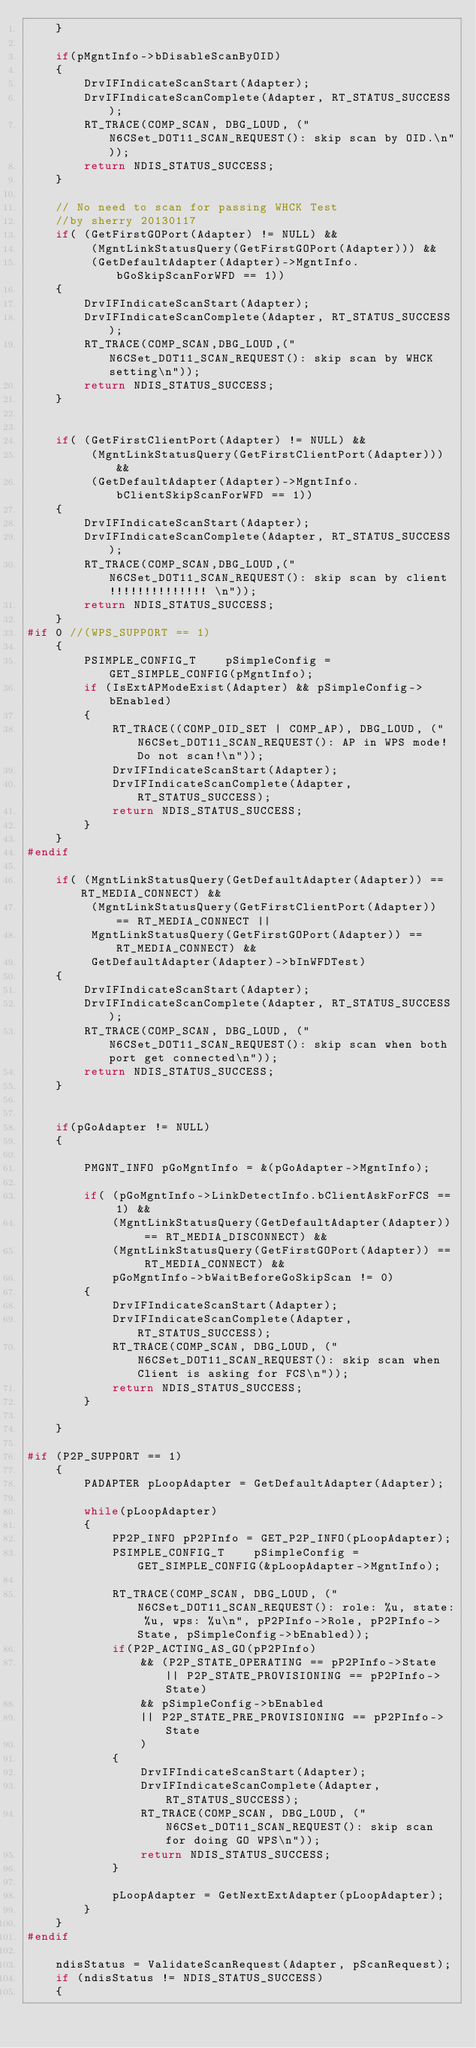Convert code to text. <code><loc_0><loc_0><loc_500><loc_500><_C_>	}

	if(pMgntInfo->bDisableScanByOID)
	{
		DrvIFIndicateScanStart(Adapter);
		DrvIFIndicateScanComplete(Adapter, RT_STATUS_SUCCESS);
		RT_TRACE(COMP_SCAN, DBG_LOUD, ("N6CSet_DOT11_SCAN_REQUEST(): skip scan by OID.\n"));
		return NDIS_STATUS_SUCCESS;
	}

	// No need to scan for passing WHCK Test 
	//by sherry 20130117
	if( (GetFirstGOPort(Adapter) != NULL) && 
		 (MgntLinkStatusQuery(GetFirstGOPort(Adapter))) &&
		 (GetDefaultAdapter(Adapter)->MgntInfo.bGoSkipScanForWFD == 1))
	{
		DrvIFIndicateScanStart(Adapter);
		DrvIFIndicateScanComplete(Adapter, RT_STATUS_SUCCESS);
		RT_TRACE(COMP_SCAN,DBG_LOUD,("N6CSet_DOT11_SCAN_REQUEST(): skip scan by WHCK setting\n"));
		return NDIS_STATUS_SUCCESS;
	}

	
	if( (GetFirstClientPort(Adapter) != NULL) && 
		 (MgntLinkStatusQuery(GetFirstClientPort(Adapter))) &&
		 (GetDefaultAdapter(Adapter)->MgntInfo.bClientSkipScanForWFD == 1))
	{
		DrvIFIndicateScanStart(Adapter);
		DrvIFIndicateScanComplete(Adapter, RT_STATUS_SUCCESS);
		RT_TRACE(COMP_SCAN,DBG_LOUD,("N6CSet_DOT11_SCAN_REQUEST(): skip scan by client!!!!!!!!!!!!!! \n"));
		return NDIS_STATUS_SUCCESS;
	}
#if 0 //(WPS_SUPPORT == 1)
	{
		PSIMPLE_CONFIG_T	pSimpleConfig = GET_SIMPLE_CONFIG(pMgntInfo);
		if (IsExtAPModeExist(Adapter) && pSimpleConfig->bEnabled)
		{
			RT_TRACE((COMP_OID_SET | COMP_AP), DBG_LOUD, ("N6CSet_DOT11_SCAN_REQUEST(): AP in WPS mode! Do not scan!\n"));
			DrvIFIndicateScanStart(Adapter);
			DrvIFIndicateScanComplete(Adapter, RT_STATUS_SUCCESS);
			return NDIS_STATUS_SUCCESS;
		}
	}
#endif

	if( (MgntLinkStatusQuery(GetDefaultAdapter(Adapter)) == RT_MEDIA_CONNECT) &&
		 (MgntLinkStatusQuery(GetFirstClientPort(Adapter)) == RT_MEDIA_CONNECT ||
		 MgntLinkStatusQuery(GetFirstGOPort(Adapter)) == RT_MEDIA_CONNECT) &&
		 GetDefaultAdapter(Adapter)->bInWFDTest)
	{
		DrvIFIndicateScanStart(Adapter);
		DrvIFIndicateScanComplete(Adapter, RT_STATUS_SUCCESS);
		RT_TRACE(COMP_SCAN, DBG_LOUD, ("N6CSet_DOT11_SCAN_REQUEST(): skip scan when both port get connected\n"));
		return NDIS_STATUS_SUCCESS;
	}


	if(pGoAdapter != NULL)
	{

		PMGNT_INFO pGoMgntInfo = &(pGoAdapter->MgntInfo);
		
		if(	(pGoMgntInfo->LinkDetectInfo.bClientAskForFCS == 1) &&	
			(MgntLinkStatusQuery(GetDefaultAdapter(Adapter)) == RT_MEDIA_DISCONNECT) &&
			(MgntLinkStatusQuery(GetFirstGOPort(Adapter)) == RT_MEDIA_CONNECT) &&
		 	pGoMgntInfo->bWaitBeforeGoSkipScan != 0)
		{
			DrvIFIndicateScanStart(Adapter);
			DrvIFIndicateScanComplete(Adapter, RT_STATUS_SUCCESS);
			RT_TRACE(COMP_SCAN, DBG_LOUD, ("N6CSet_DOT11_SCAN_REQUEST(): skip scan when Client is asking for FCS\n"));
			return NDIS_STATUS_SUCCESS;
		}
	
	}
	
#if (P2P_SUPPORT == 1)
	{
		PADAPTER pLoopAdapter = GetDefaultAdapter(Adapter);

		while(pLoopAdapter)
		{
			PP2P_INFO pP2PInfo = GET_P2P_INFO(pLoopAdapter);
			PSIMPLE_CONFIG_T	pSimpleConfig = GET_SIMPLE_CONFIG(&pLoopAdapter->MgntInfo);
			
			RT_TRACE(COMP_SCAN, DBG_LOUD, ("N6CSet_DOT11_SCAN_REQUEST(): role: %u, state: %u, wps: %u\n", pP2PInfo->Role, pP2PInfo->State, pSimpleConfig->bEnabled));
			if(P2P_ACTING_AS_GO(pP2PInfo)
				&& (P2P_STATE_OPERATING == pP2PInfo->State || P2P_STATE_PROVISIONING == pP2PInfo->State)
				&& pSimpleConfig->bEnabled
				|| P2P_STATE_PRE_PROVISIONING == pP2PInfo->State
				)
			{
				DrvIFIndicateScanStart(Adapter);
				DrvIFIndicateScanComplete(Adapter, RT_STATUS_SUCCESS);
				RT_TRACE(COMP_SCAN, DBG_LOUD, ("N6CSet_DOT11_SCAN_REQUEST(): skip scan for doing GO WPS\n"));
				return NDIS_STATUS_SUCCESS;
			}

			pLoopAdapter = GetNextExtAdapter(pLoopAdapter);
		}
	}
#endif

	ndisStatus = ValidateScanRequest(Adapter, pScanRequest);
	if (ndisStatus != NDIS_STATUS_SUCCESS)
	{</code> 